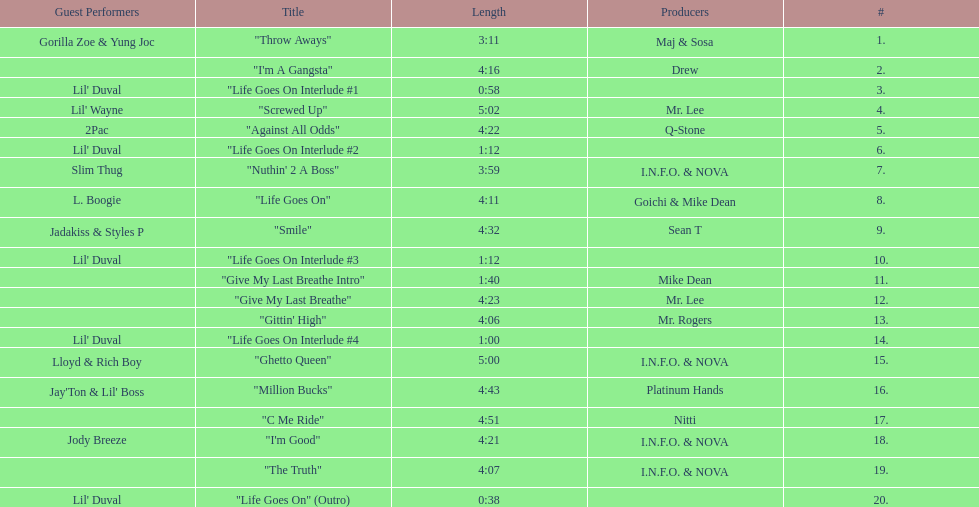Parse the full table. {'header': ['Guest Performers', 'Title', 'Length', 'Producers', '#'], 'rows': [['Gorilla Zoe & Yung Joc', '"Throw Aways"', '3:11', 'Maj & Sosa', '1.'], ['', '"I\'m A Gangsta"', '4:16', 'Drew', '2.'], ["Lil' Duval", '"Life Goes On Interlude #1', '0:58', '', '3.'], ["Lil' Wayne", '"Screwed Up"', '5:02', 'Mr. Lee', '4.'], ['2Pac', '"Against All Odds"', '4:22', 'Q-Stone', '5.'], ["Lil' Duval", '"Life Goes On Interlude #2', '1:12', '', '6.'], ['Slim Thug', '"Nuthin\' 2 A Boss"', '3:59', 'I.N.F.O. & NOVA', '7.'], ['L. Boogie', '"Life Goes On"', '4:11', 'Goichi & Mike Dean', '8.'], ['Jadakiss & Styles P', '"Smile"', '4:32', 'Sean T', '9.'], ["Lil' Duval", '"Life Goes On Interlude #3', '1:12', '', '10.'], ['', '"Give My Last Breathe Intro"', '1:40', 'Mike Dean', '11.'], ['', '"Give My Last Breathe"', '4:23', 'Mr. Lee', '12.'], ['', '"Gittin\' High"', '4:06', 'Mr. Rogers', '13.'], ["Lil' Duval", '"Life Goes On Interlude #4', '1:00', '', '14.'], ['Lloyd & Rich Boy', '"Ghetto Queen"', '5:00', 'I.N.F.O. & NOVA', '15.'], ["Jay'Ton & Lil' Boss", '"Million Bucks"', '4:43', 'Platinum Hands', '16.'], ['', '"C Me Ride"', '4:51', 'Nitti', '17.'], ['Jody Breeze', '"I\'m Good"', '4:21', 'I.N.F.O. & NOVA', '18.'], ['', '"The Truth"', '4:07', 'I.N.F.O. & NOVA', '19.'], ["Lil' Duval", '"Life Goes On" (Outro)', '0:38', '', '20.']]} What is the lengthiest track on the album? "Screwed Up". 